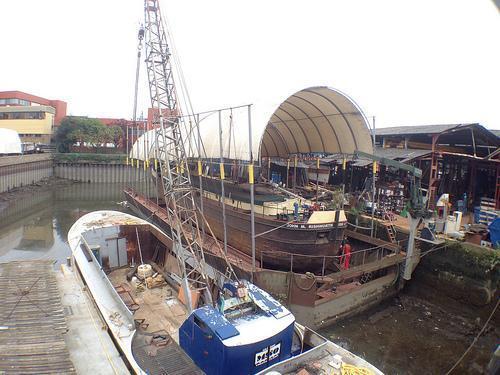How many boats are there?
Give a very brief answer. 2. 